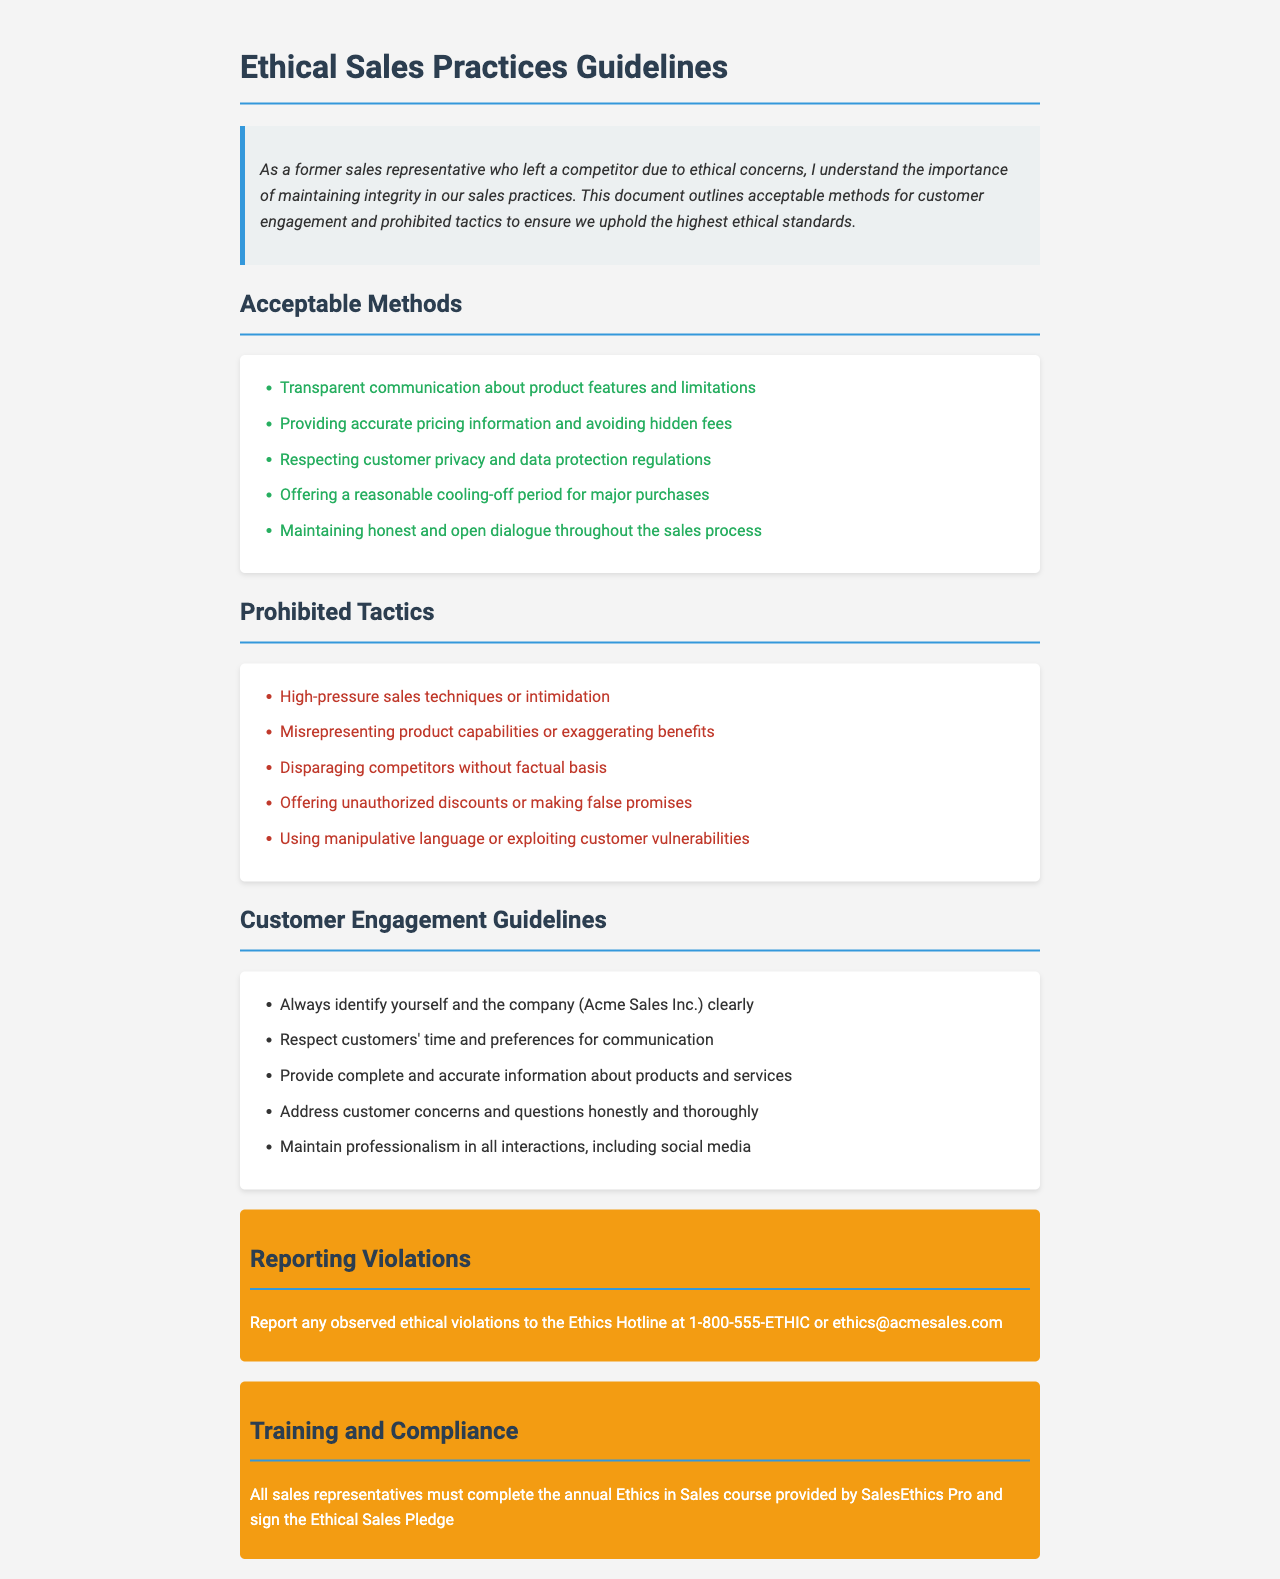What are the acceptable methods for customer engagement? The acceptable methods are listed in the section titled "Acceptable Methods," which details various practices that align with ethical standards.
Answer: Transparent communication, accurate pricing, respecting privacy, cooling-off period, honest dialogue What should be reported to the Ethics Hotline? Report any observed ethical violations to ensure adherence to the ethical sales practices outlined in the document.
Answer: Ethical violations What is the contact number for the Ethics Hotline? The Ethics Hotline number is specifically provided to report violations as per the guidelines.
Answer: 1-800-555-ETHIC Which company do sales representatives represent? The first mention of the company indicates it is central to the guidelines and required for identification in customer engagements.
Answer: Acme Sales Inc What is prohibited regarding product capabilities? The Prohibited Tactics section provides specific unethical practices that should not be used in sales interactions.
Answer: Misrepresenting product capabilities What is required of sales representatives annually? The document outlines ongoing training requirements that are necessary for compliance with ethical practices.
Answer: Completion of the annual Ethics in Sales course What should sales representatives provide customers during engagement? This information is found under "Customer Engagement Guidelines," reflecting the commitment to transparency and professionalism.
Answer: Complete and accurate information What action should be taken if observing manipulative language? The document specifies that such language is prohibited and should be reported accordingly.
Answer: Report to Ethics Hotline What is the purpose of the Ethical Sales Pledge? The Pledge ensures representatives commit to ethical standards set forth in policy documents like this one.
Answer: Commitment to ethical standards 